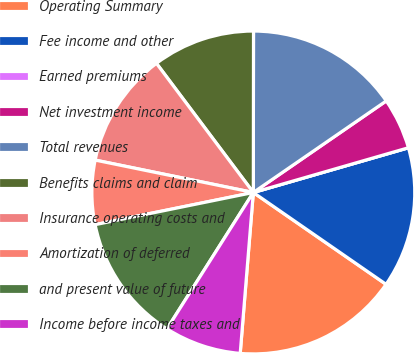Convert chart. <chart><loc_0><loc_0><loc_500><loc_500><pie_chart><fcel>Operating Summary<fcel>Fee income and other<fcel>Earned premiums<fcel>Net investment income<fcel>Total revenues<fcel>Benefits claims and claim<fcel>Insurance operating costs and<fcel>Amortization of deferred<fcel>and present value of future<fcel>Income before income taxes and<nl><fcel>16.66%<fcel>14.1%<fcel>0.0%<fcel>5.13%<fcel>15.38%<fcel>10.26%<fcel>11.54%<fcel>6.41%<fcel>12.82%<fcel>7.69%<nl></chart> 